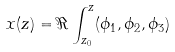Convert formula to latex. <formula><loc_0><loc_0><loc_500><loc_500>x ( z ) = \Re \int ^ { z } _ { z _ { 0 } } ( \phi _ { 1 } , \phi _ { 2 } , \phi _ { 3 } )</formula> 